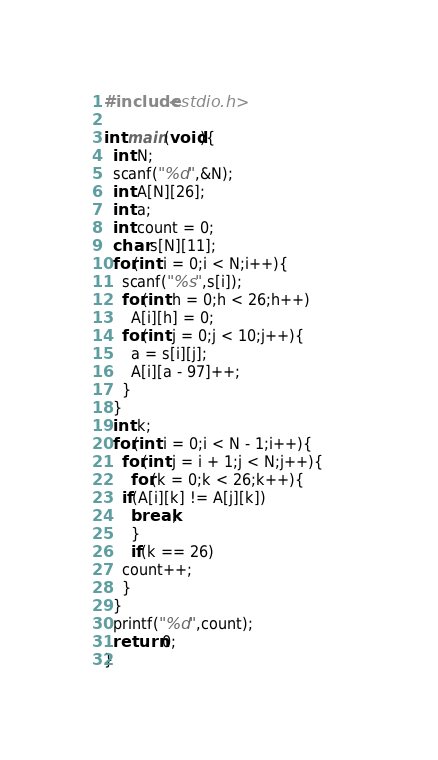Convert code to text. <code><loc_0><loc_0><loc_500><loc_500><_C_>#include<stdio.h>

int main(void){
  int N;
  scanf("%d",&N);
  int A[N][26];
  int a;
  int count = 0;
  char s[N][11];
  for(int i = 0;i < N;i++){    
    scanf("%s",s[i]);
    for(int h = 0;h < 26;h++)
      A[i][h] = 0;
    for(int j = 0;j < 10;j++){      
      a = s[i][j];
      A[i][a - 97]++;
    }
  }
  int k;
  for(int i = 0;i < N - 1;i++){
    for(int j = i + 1;j < N;j++){     
      for(k = 0;k < 26;k++){
	if(A[i][k] != A[j][k])
	  break;
      }
      if(k == 26)
	count++;
    }
  }
  printf("%d",count);
  return 0;
}
</code> 